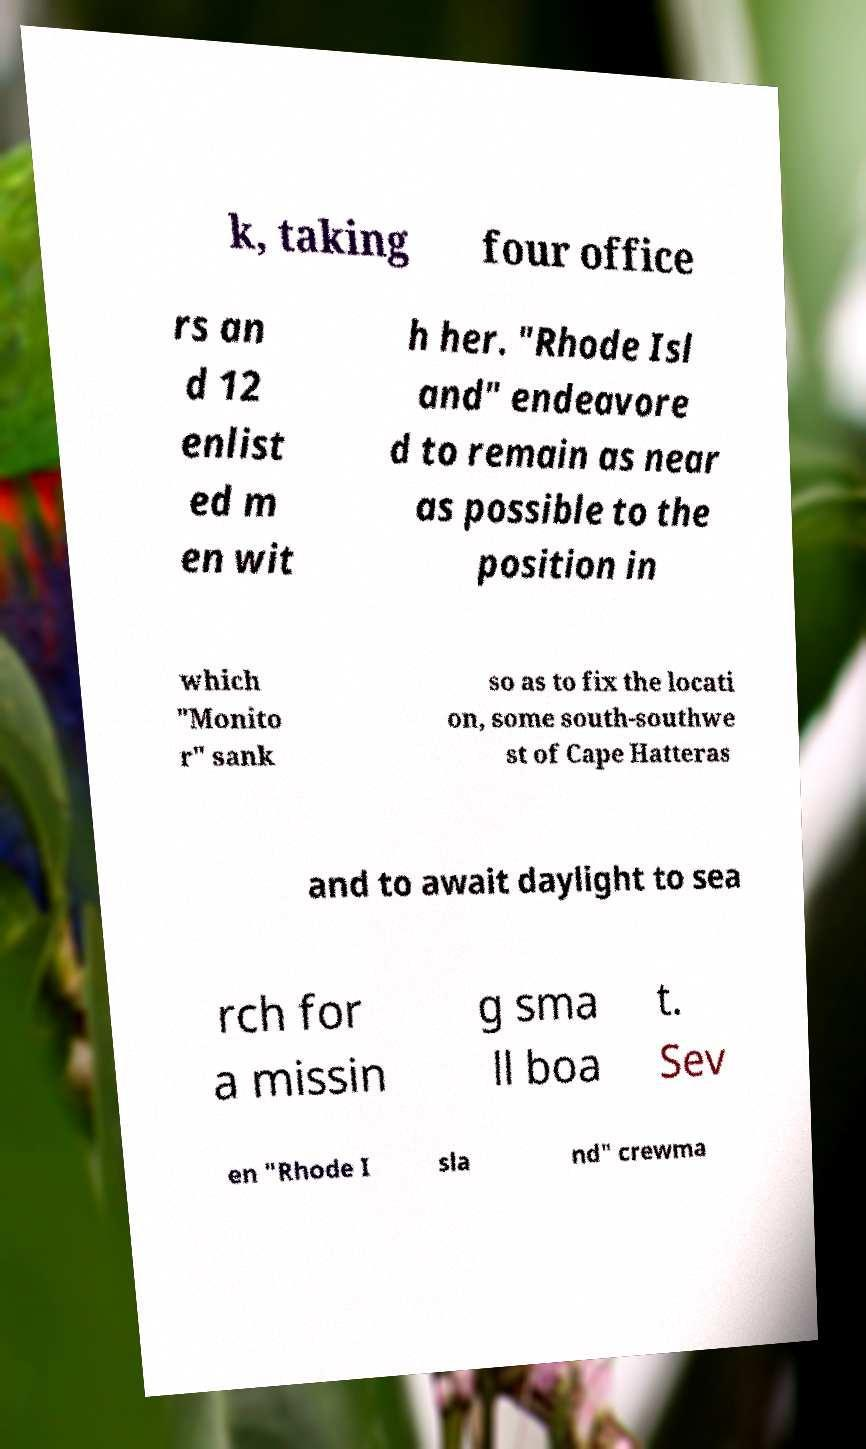Please identify and transcribe the text found in this image. k, taking four office rs an d 12 enlist ed m en wit h her. "Rhode Isl and" endeavore d to remain as near as possible to the position in which "Monito r" sank so as to fix the locati on, some south-southwe st of Cape Hatteras and to await daylight to sea rch for a missin g sma ll boa t. Sev en "Rhode I sla nd" crewma 